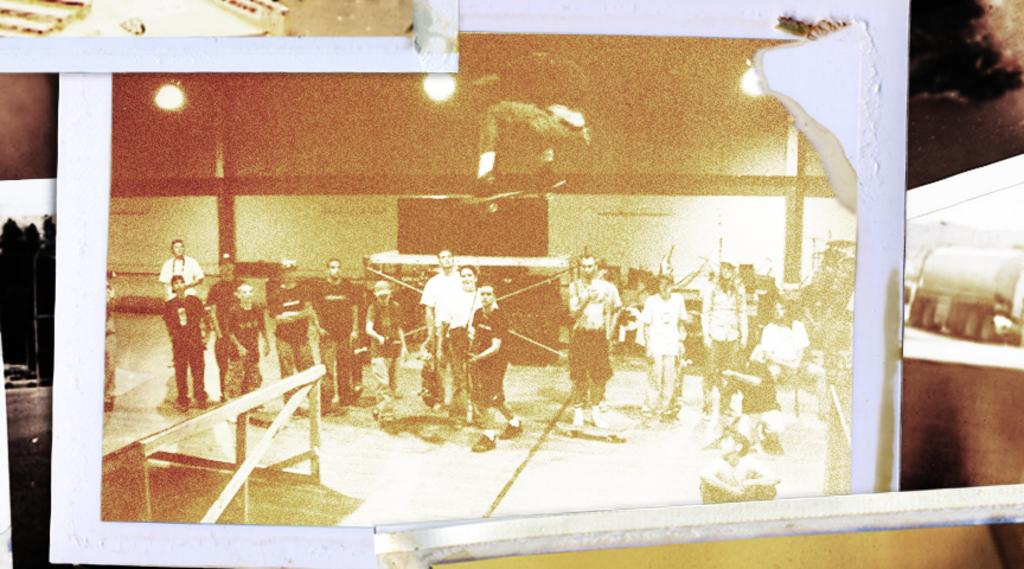How many people are in the image? There is a group of people in the image, but the exact number cannot be determined from the provided facts. What can be seen at the top of the image? There are lights visible at the top of the image. What is located in the background of the image? There is a board in the background of the image. How many tomatoes are on the bean plant in the image? There is no tomato plant or bean plant present in the image. 